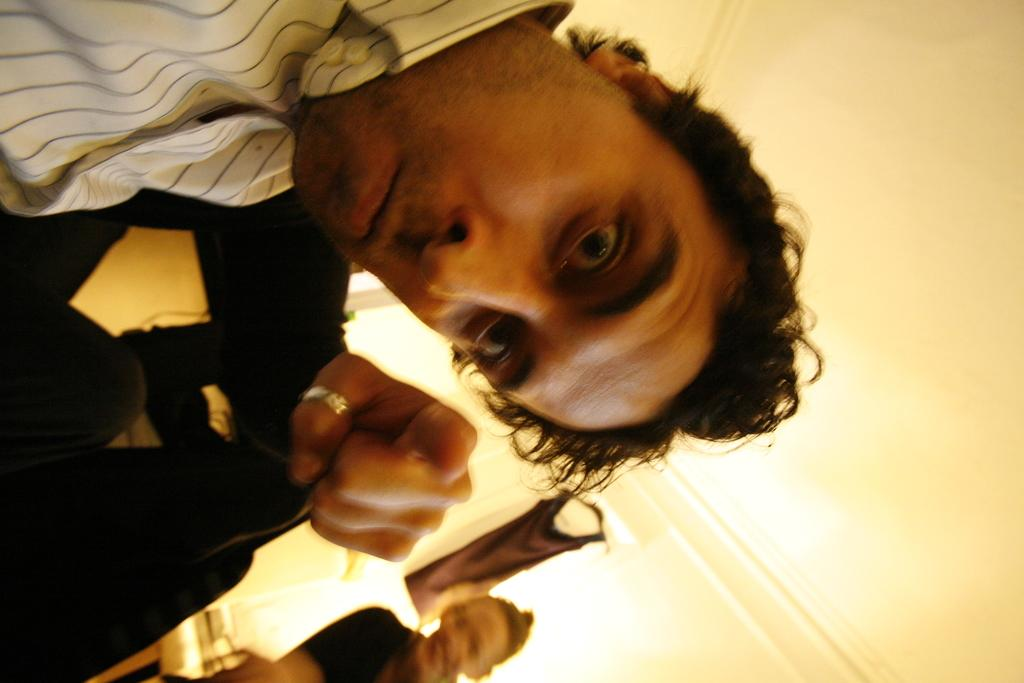How many people are present in the image? There are two people in the image. Can you describe the background of the image? There is a chair and cloth hanging on a wall in the background of the image. What type of glove is the person wearing in the image? There is no glove visible in the image; both people are wearing clothing, but no gloves are present. 